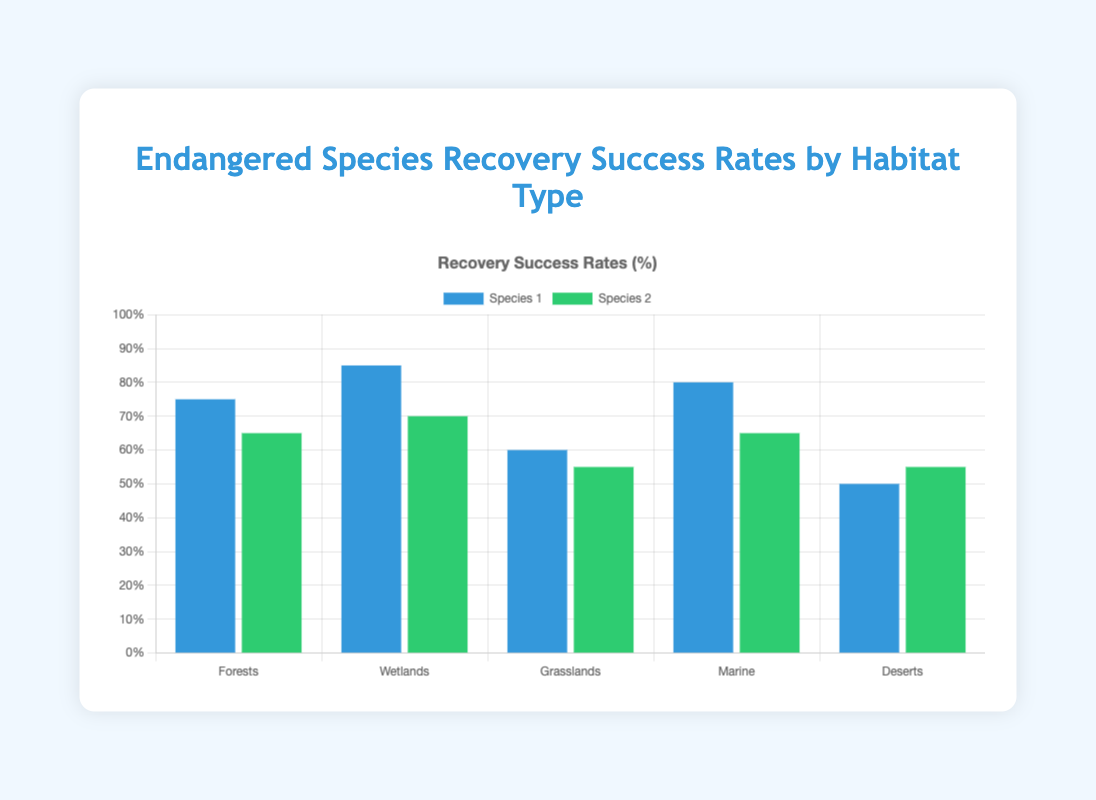Which species has the highest recovery rate in wetlands? Look for the highest bar in the Wetlands category. The highest bar represents the American Alligator with a recovery rate of 85%.
Answer: American Alligator What is the average recovery rate of species in forests? Add the recovery rates of all species in the Forests category and divide by the number of species. (75 + 65)/2 = 70
Answer: 70 How much higher is the recovery rate of the Humpback Whale compared to the Green Sea Turtle? Subtract the recovery rate of the Green Sea Turtle from that of the Humpback Whale. 80 - 65 = 15
Answer: 15 Which habitat has the most even recovery rates between the two species? Compare the differences in recovery rates between species in each habitat. The smallest difference is found in Deserts (55 - 50 = 5)
Answer: Deserts Which species in marine habitats has a higher recovery rate? Compare the heights of the bars in the Marine category. The Humpback Whale has a higher recovery rate of 80% compared to the Green Sea Turtle's 65%.
Answer: Humpback Whale What is the total recovery rate for all species in deserts? Add the recovery rates for both species in the Deserts category. 50 + 55 = 105
Answer: 105 Which habitat has the lowest average species recovery rate? Calculate the average recovery rates for each habitat and compare them. Deserts have the lowest average recovery rate ((50 + 55)/2 = 52.5)
Answer: Deserts How much greater is the recovery rate of the American Alligator compared to the Black-Footed Ferret? Subtract the recovery rate of the Black-Footed Ferret from that of the American Alligator. 85 - 60 = 25
Answer: 25 Which species has the lowest recovery rate in forests? Compare the heights of the bars in the Forests category. The Northern Spotted Owl has the lowest recovery rate of 65%.
Answer: Northern Spotted Owl Do more species have recovery rates higher than 70% in marine habitats or wetlands? Count the number of species with a recovery rate higher than 70% in both habitats. Only the Humpback Whale in Marine (1), and both species in Wetlands (2).
Answer: Wetlands 